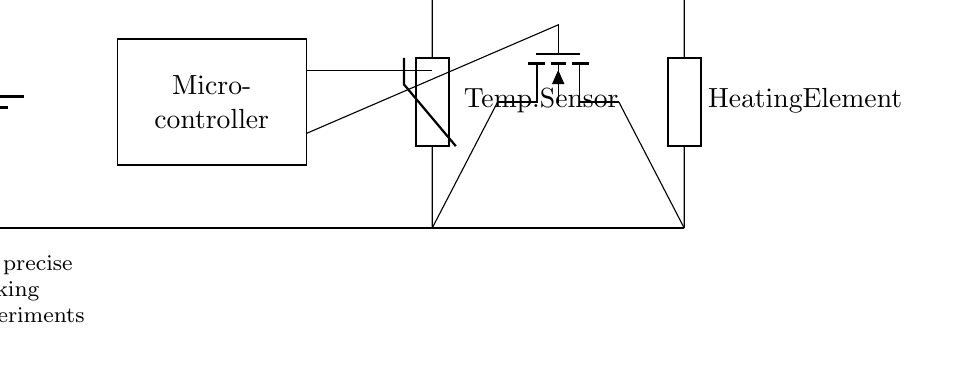What is the power supply component in the circuit? The power supply component is identified as a battery labeled as Vcc in the diagram. This is the source providing power to the circuit.
Answer: battery What type of sensor is used in the circuit? The sensor used in the circuit is a thermistor, which is indicated in the circuit diagram. This component is responsible for measuring temperature.
Answer: thermistor How many main components are there in the circuit? The main components are the battery, microcontroller, thermistor, heating element, and MOSFET, totaling five distinct components in the circuit.
Answer: five What role does the MOSFET play in this circuit? The MOSFET acts as a switch that controls the power supplied to the heating element based on the feedback from the microcontroller. It is connected to the heating element and temperature sensor for precise control.
Answer: switch Which component provides feedback to the microcontroller? The thermistor serves as the feedback component to the microcontroller by providing temperature readings that allow the microcontroller to make necessary adjustments to the heating element.
Answer: thermistor What type of circuit is this primarily designed for? The circuit is primarily designed for temperature control in cooking experiments to achieve precise cooking conditions.
Answer: cooking experiments 